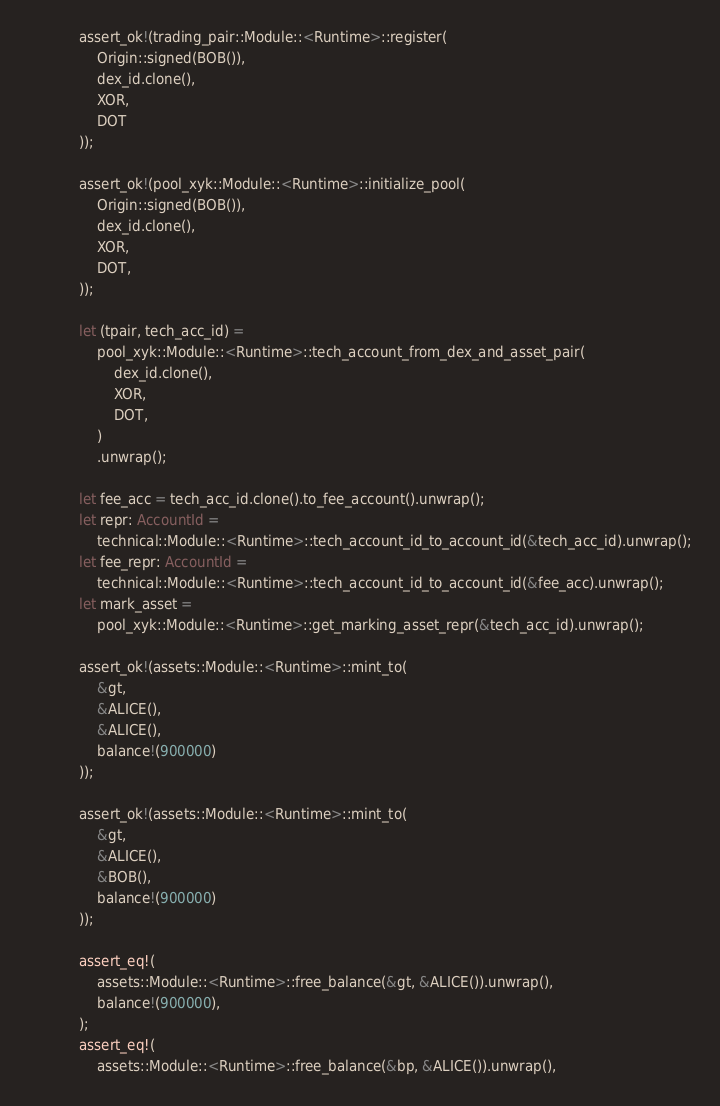<code> <loc_0><loc_0><loc_500><loc_500><_Rust_>
            assert_ok!(trading_pair::Module::<Runtime>::register(
                Origin::signed(BOB()),
                dex_id.clone(),
                XOR,
                DOT
            ));

            assert_ok!(pool_xyk::Module::<Runtime>::initialize_pool(
                Origin::signed(BOB()),
                dex_id.clone(),
                XOR,
                DOT,
            ));

            let (tpair, tech_acc_id) =
                pool_xyk::Module::<Runtime>::tech_account_from_dex_and_asset_pair(
                    dex_id.clone(),
                    XOR,
                    DOT,
                )
                .unwrap();

            let fee_acc = tech_acc_id.clone().to_fee_account().unwrap();
            let repr: AccountId =
                technical::Module::<Runtime>::tech_account_id_to_account_id(&tech_acc_id).unwrap();
            let fee_repr: AccountId =
                technical::Module::<Runtime>::tech_account_id_to_account_id(&fee_acc).unwrap();
            let mark_asset =
                pool_xyk::Module::<Runtime>::get_marking_asset_repr(&tech_acc_id).unwrap();

            assert_ok!(assets::Module::<Runtime>::mint_to(
                &gt,
                &ALICE(),
                &ALICE(),
                balance!(900000)
            ));

            assert_ok!(assets::Module::<Runtime>::mint_to(
                &gt,
                &ALICE(),
                &BOB(),
                balance!(900000)
            ));

            assert_eq!(
                assets::Module::<Runtime>::free_balance(&gt, &ALICE()).unwrap(),
                balance!(900000),
            );
            assert_eq!(
                assets::Module::<Runtime>::free_balance(&bp, &ALICE()).unwrap(),</code> 